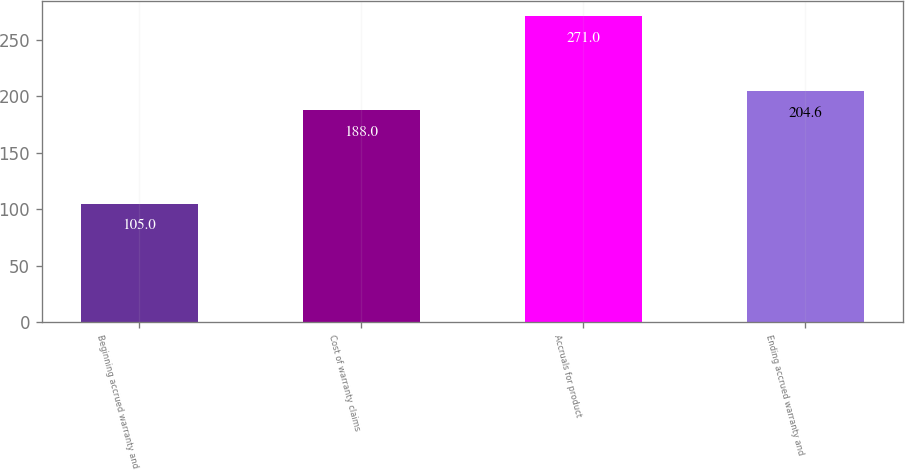Convert chart to OTSL. <chart><loc_0><loc_0><loc_500><loc_500><bar_chart><fcel>Beginning accrued warranty and<fcel>Cost of warranty claims<fcel>Accruals for product<fcel>Ending accrued warranty and<nl><fcel>105<fcel>188<fcel>271<fcel>204.6<nl></chart> 